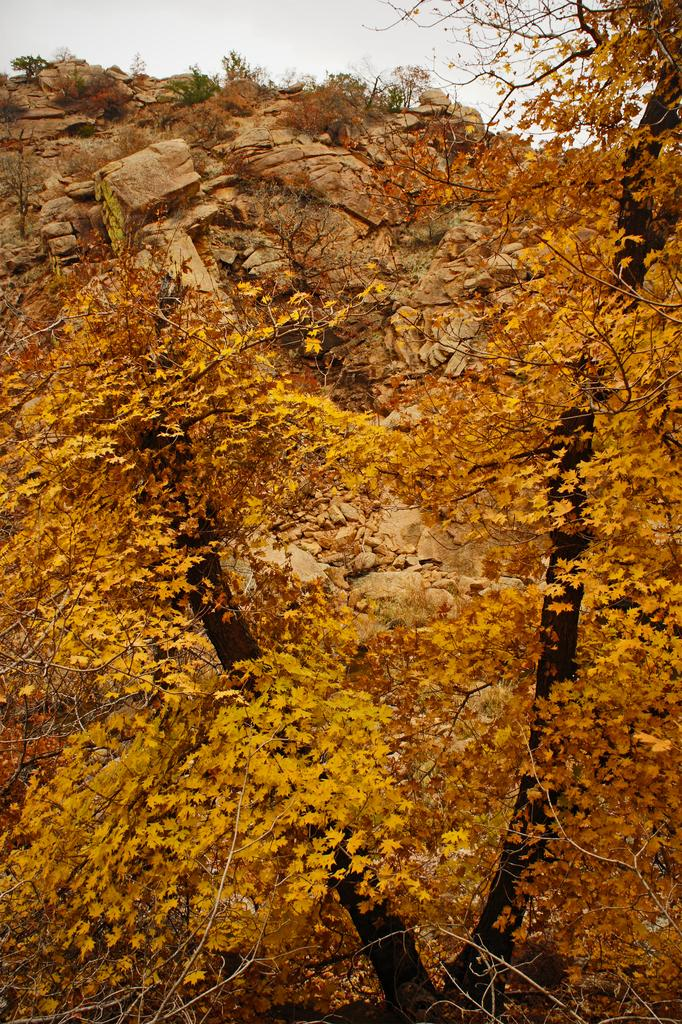What type of vegetation can be seen in the image? There are trees with colorful leaves in the image. What natural features are present in the background of the image? There are mountains in the image. What is visible above the trees and mountains in the image? There is a sky visible in the image. What type of pin is holding the trees in place in the image? There is no pin present in the image; the trees are standing on their own. What type of trousers are the mountains wearing in the image? There are no trousers present in the image, as mountains are not capable of wearing clothing. 